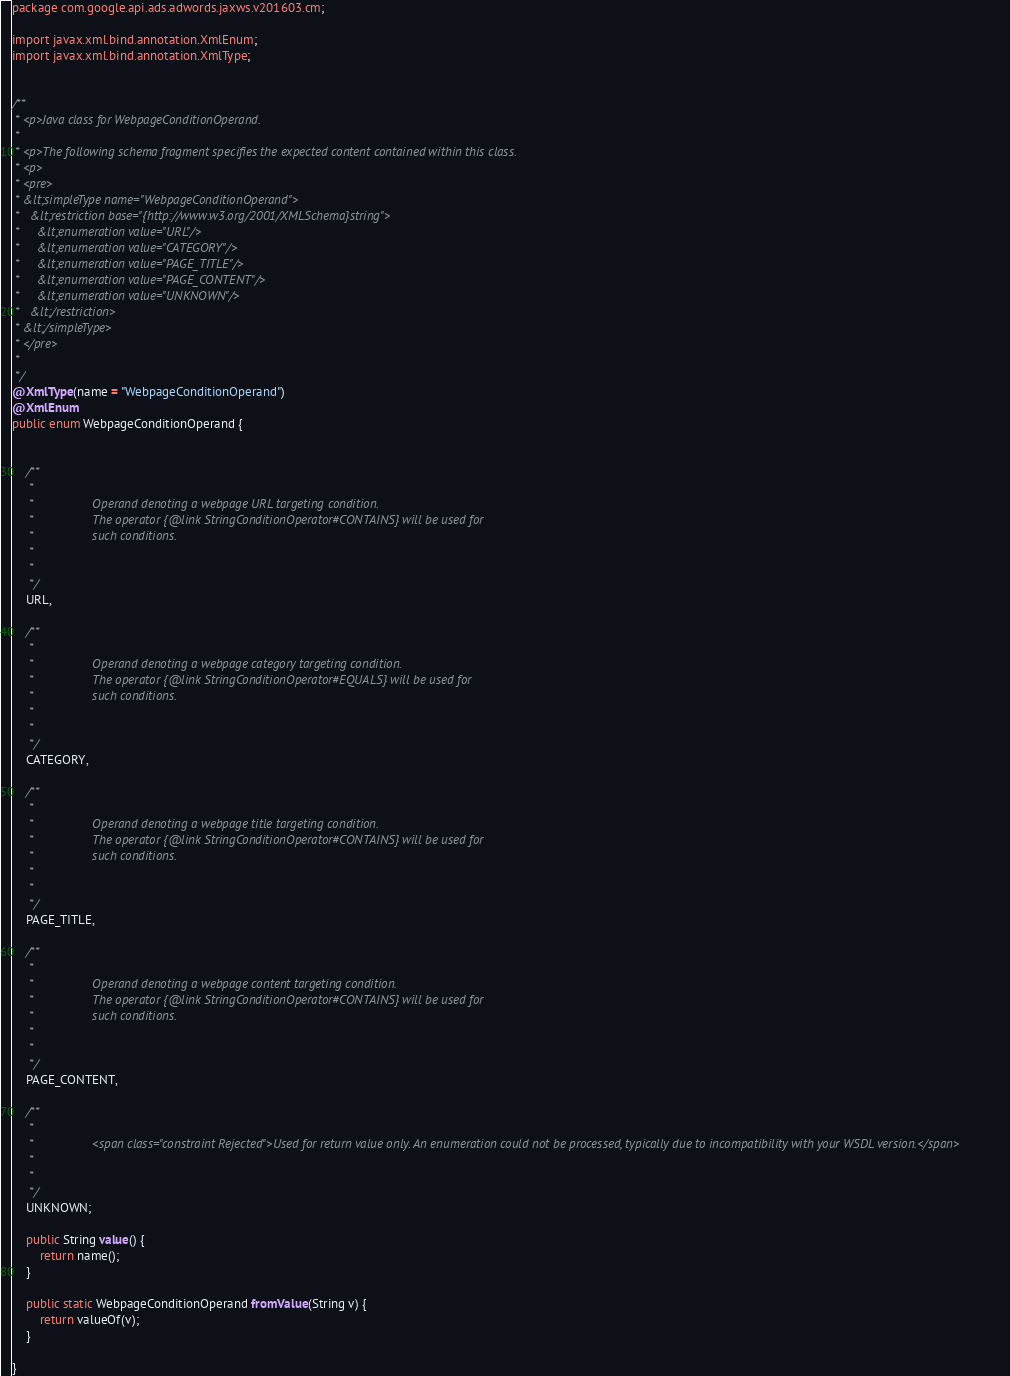Convert code to text. <code><loc_0><loc_0><loc_500><loc_500><_Java_>
package com.google.api.ads.adwords.jaxws.v201603.cm;

import javax.xml.bind.annotation.XmlEnum;
import javax.xml.bind.annotation.XmlType;


/**
 * <p>Java class for WebpageConditionOperand.
 * 
 * <p>The following schema fragment specifies the expected content contained within this class.
 * <p>
 * <pre>
 * &lt;simpleType name="WebpageConditionOperand">
 *   &lt;restriction base="{http://www.w3.org/2001/XMLSchema}string">
 *     &lt;enumeration value="URL"/>
 *     &lt;enumeration value="CATEGORY"/>
 *     &lt;enumeration value="PAGE_TITLE"/>
 *     &lt;enumeration value="PAGE_CONTENT"/>
 *     &lt;enumeration value="UNKNOWN"/>
 *   &lt;/restriction>
 * &lt;/simpleType>
 * </pre>
 * 
 */
@XmlType(name = "WebpageConditionOperand")
@XmlEnum
public enum WebpageConditionOperand {


    /**
     * 
     *                 Operand denoting a webpage URL targeting condition.
     *                 The operator {@link StringConditionOperator#CONTAINS} will be used for
     *                 such conditions.
     *               
     * 
     */
    URL,

    /**
     * 
     *                 Operand denoting a webpage category targeting condition.
     *                 The operator {@link StringConditionOperator#EQUALS} will be used for
     *                 such conditions.
     *               
     * 
     */
    CATEGORY,

    /**
     * 
     *                 Operand denoting a webpage title targeting condition.
     *                 The operator {@link StringConditionOperator#CONTAINS} will be used for
     *                 such conditions.
     *               
     * 
     */
    PAGE_TITLE,

    /**
     * 
     *                 Operand denoting a webpage content targeting condition.
     *                 The operator {@link StringConditionOperator#CONTAINS} will be used for
     *                 such conditions.
     *               
     * 
     */
    PAGE_CONTENT,

    /**
     * 
     *                 <span class="constraint Rejected">Used for return value only. An enumeration could not be processed, typically due to incompatibility with your WSDL version.</span>
     *               
     * 
     */
    UNKNOWN;

    public String value() {
        return name();
    }

    public static WebpageConditionOperand fromValue(String v) {
        return valueOf(v);
    }

}
</code> 